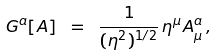Convert formula to latex. <formula><loc_0><loc_0><loc_500><loc_500>G ^ { a } [ A ] \ = \ \frac { 1 } { ( \eta ^ { 2 } ) ^ { 1 / 2 } } \, \eta ^ { \mu } A ^ { a } _ { \mu } \, ,</formula> 